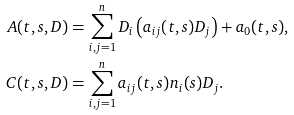<formula> <loc_0><loc_0><loc_500><loc_500>A ( t , s , D ) & = \sum _ { i , j = 1 } ^ { n } D _ { i } \left ( a _ { i j } ( t , s ) D _ { j } \right ) + a _ { 0 } ( t , s ) , \\ C ( t , s , D ) & = \sum _ { i , j = 1 } ^ { n } a _ { i j } ( t , s ) n _ { i } ( s ) D _ { j } .</formula> 